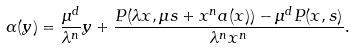<formula> <loc_0><loc_0><loc_500><loc_500>\alpha ( y ) = \frac { \mu ^ { d } } { \lambda ^ { n } } y + \frac { P ( \lambda x , \mu s + x ^ { n } a ( x ) ) - \mu ^ { d } P ( x , s ) } { \lambda ^ { n } x ^ { n } } .</formula> 